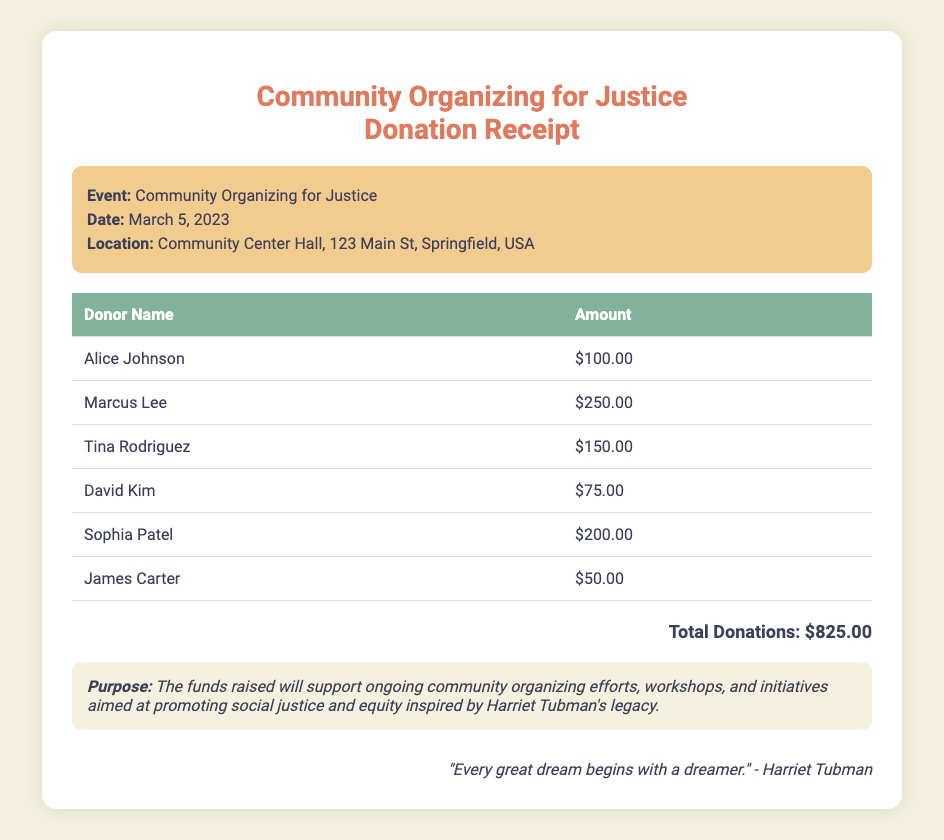What is the total donation amount? The total donation amount is listed at the bottom of the document, calculated from the individual contributions.
Answer: $825.00 Who is one of the donors? The document lists multiple donors' names, providing specific contributions made.
Answer: Alice Johnson What is the purpose of the funds raised? The purpose of the funds is described in a specific section of the document highlighting the goals for the money.
Answer: Support ongoing community organizing efforts When was the event held? The date of the event is mentioned in the event details section of the document.
Answer: March 5, 2023 Where was the event location? The location is specified in the event details section, containing the venue and address.
Answer: Community Center Hall, 123 Main St, Springfield, USA How many donors contributed? The document features a table with individual contributions, which allows for counting the number of donors.
Answer: 6 What is the donation amount from Marcus Lee? Each donor's contribution is detailed in the table, indicating the specific amount contributed by Marcus Lee.
Answer: $250.00 